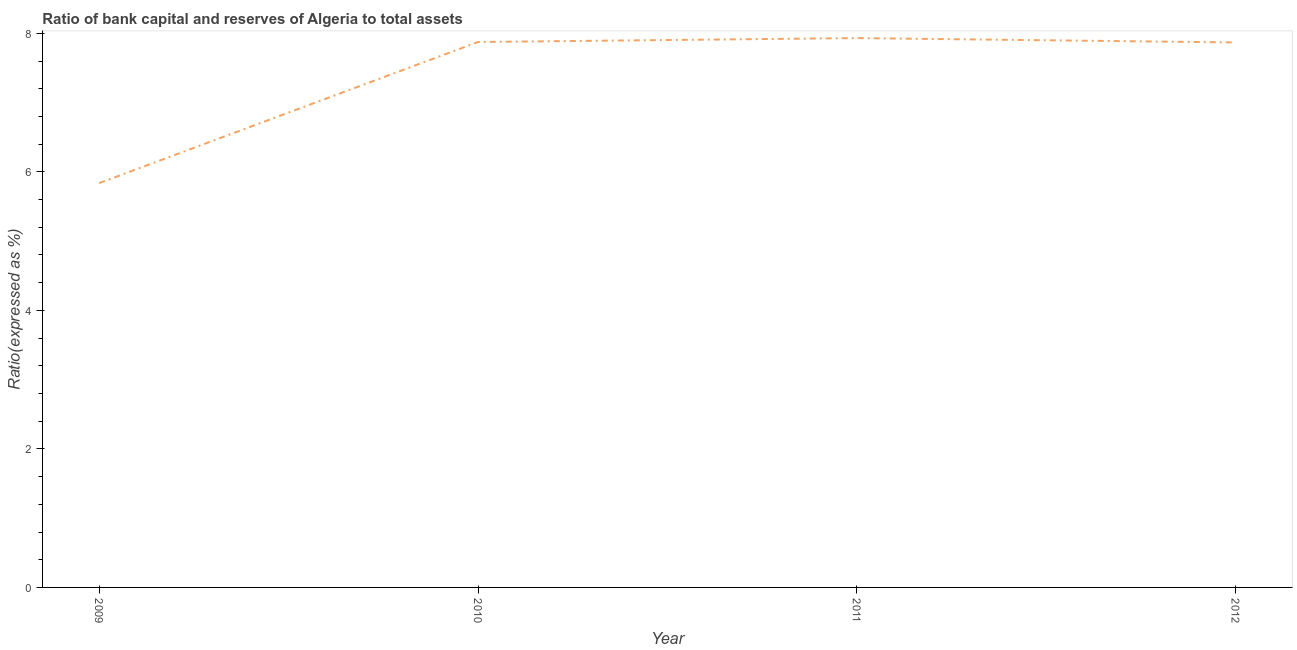What is the bank capital to assets ratio in 2012?
Your answer should be compact. 7.87. Across all years, what is the maximum bank capital to assets ratio?
Make the answer very short. 7.93. Across all years, what is the minimum bank capital to assets ratio?
Make the answer very short. 5.84. What is the sum of the bank capital to assets ratio?
Your response must be concise. 29.51. What is the difference between the bank capital to assets ratio in 2010 and 2012?
Give a very brief answer. 0.01. What is the average bank capital to assets ratio per year?
Ensure brevity in your answer.  7.38. What is the median bank capital to assets ratio?
Offer a terse response. 7.87. What is the ratio of the bank capital to assets ratio in 2009 to that in 2010?
Provide a short and direct response. 0.74. What is the difference between the highest and the second highest bank capital to assets ratio?
Keep it short and to the point. 0.06. Is the sum of the bank capital to assets ratio in 2009 and 2012 greater than the maximum bank capital to assets ratio across all years?
Your answer should be very brief. Yes. What is the difference between the highest and the lowest bank capital to assets ratio?
Offer a terse response. 2.09. In how many years, is the bank capital to assets ratio greater than the average bank capital to assets ratio taken over all years?
Make the answer very short. 3. How many years are there in the graph?
Keep it short and to the point. 4. What is the title of the graph?
Offer a very short reply. Ratio of bank capital and reserves of Algeria to total assets. What is the label or title of the X-axis?
Give a very brief answer. Year. What is the label or title of the Y-axis?
Give a very brief answer. Ratio(expressed as %). What is the Ratio(expressed as %) in 2009?
Your answer should be compact. 5.84. What is the Ratio(expressed as %) in 2010?
Your answer should be compact. 7.88. What is the Ratio(expressed as %) in 2011?
Offer a terse response. 7.93. What is the Ratio(expressed as %) in 2012?
Give a very brief answer. 7.87. What is the difference between the Ratio(expressed as %) in 2009 and 2010?
Keep it short and to the point. -2.04. What is the difference between the Ratio(expressed as %) in 2009 and 2011?
Ensure brevity in your answer.  -2.09. What is the difference between the Ratio(expressed as %) in 2009 and 2012?
Offer a very short reply. -2.03. What is the difference between the Ratio(expressed as %) in 2010 and 2011?
Give a very brief answer. -0.06. What is the difference between the Ratio(expressed as %) in 2010 and 2012?
Make the answer very short. 0.01. What is the difference between the Ratio(expressed as %) in 2011 and 2012?
Your response must be concise. 0.06. What is the ratio of the Ratio(expressed as %) in 2009 to that in 2010?
Offer a very short reply. 0.74. What is the ratio of the Ratio(expressed as %) in 2009 to that in 2011?
Offer a very short reply. 0.74. What is the ratio of the Ratio(expressed as %) in 2009 to that in 2012?
Make the answer very short. 0.74. What is the ratio of the Ratio(expressed as %) in 2010 to that in 2011?
Ensure brevity in your answer.  0.99. What is the ratio of the Ratio(expressed as %) in 2010 to that in 2012?
Offer a very short reply. 1. What is the ratio of the Ratio(expressed as %) in 2011 to that in 2012?
Provide a short and direct response. 1.01. 